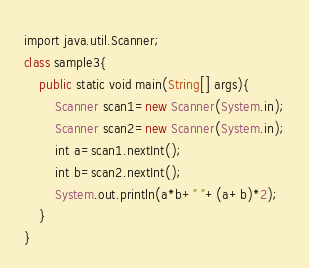Convert code to text. <code><loc_0><loc_0><loc_500><loc_500><_Ruby_>import java.util.Scanner;
class sample3{
    public static void main(String[] args){
        Scanner scan1=new Scanner(System.in);
        Scanner scan2=new Scanner(System.in);
        int a=scan1.nextInt();
        int b=scan2.nextInt();
        System.out.println(a*b+" "+(a+b)*2);
    }
}</code> 